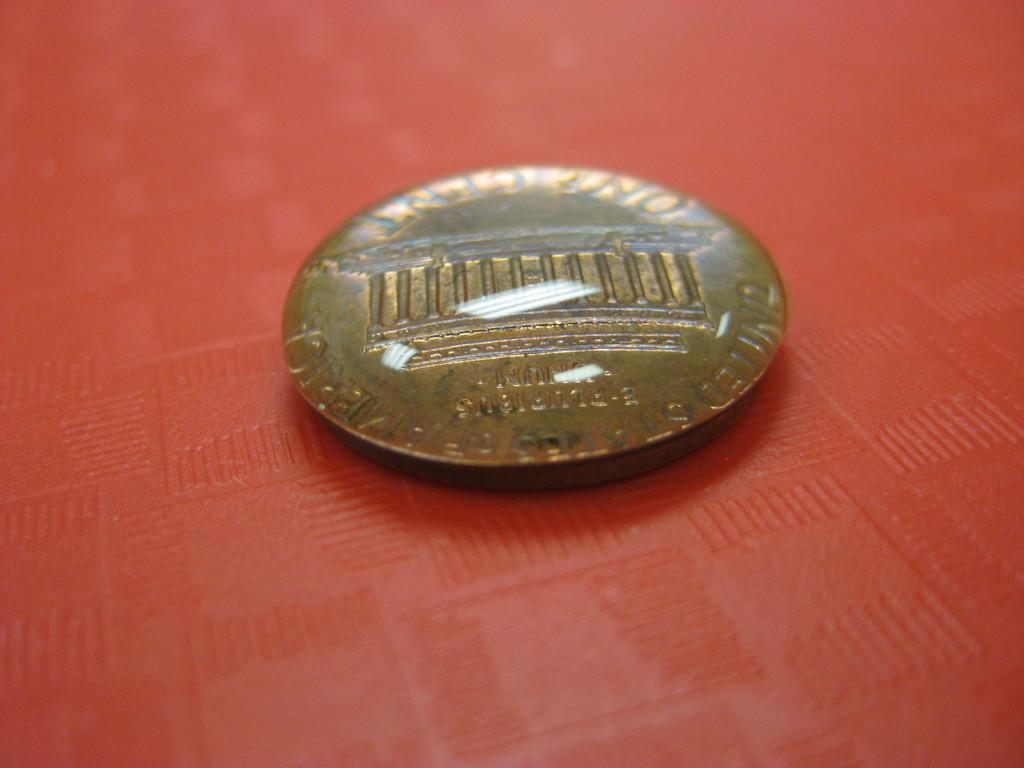<image>
Write a terse but informative summary of the picture. a close up of a One Cent coin on a red table 